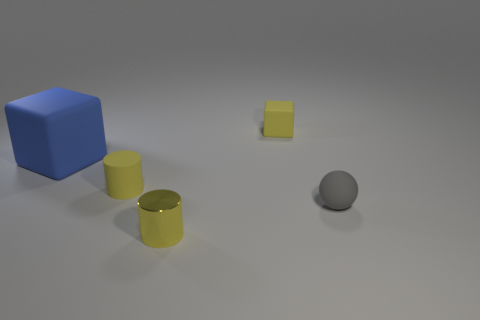Add 5 gray balls. How many objects exist? 10 Subtract all cubes. How many objects are left? 3 Add 5 small gray rubber things. How many small gray rubber things exist? 6 Subtract 0 brown balls. How many objects are left? 5 Subtract all tiny yellow matte spheres. Subtract all blue matte cubes. How many objects are left? 4 Add 3 yellow matte objects. How many yellow matte objects are left? 5 